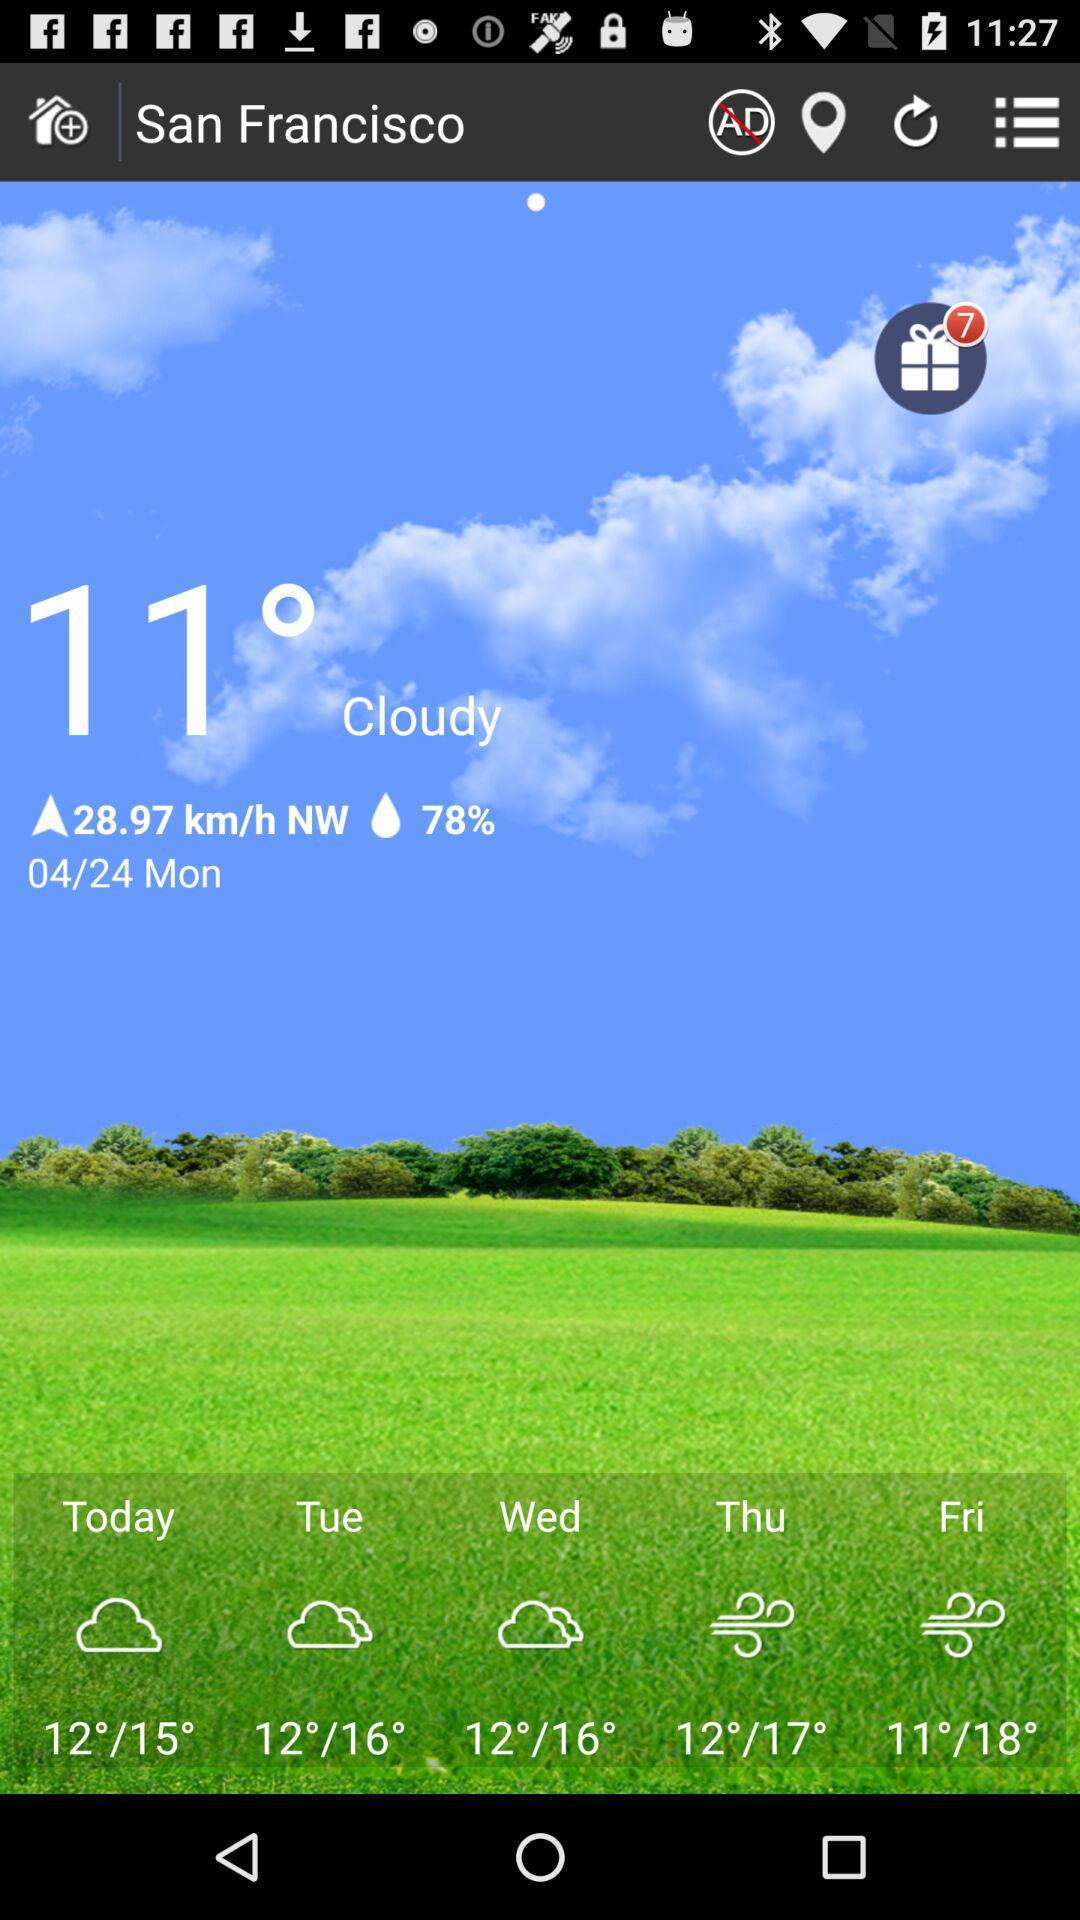How many degrees warmer is the low temperature for Thursday than the low temperature for Friday?
Answer the question using a single word or phrase. 1 